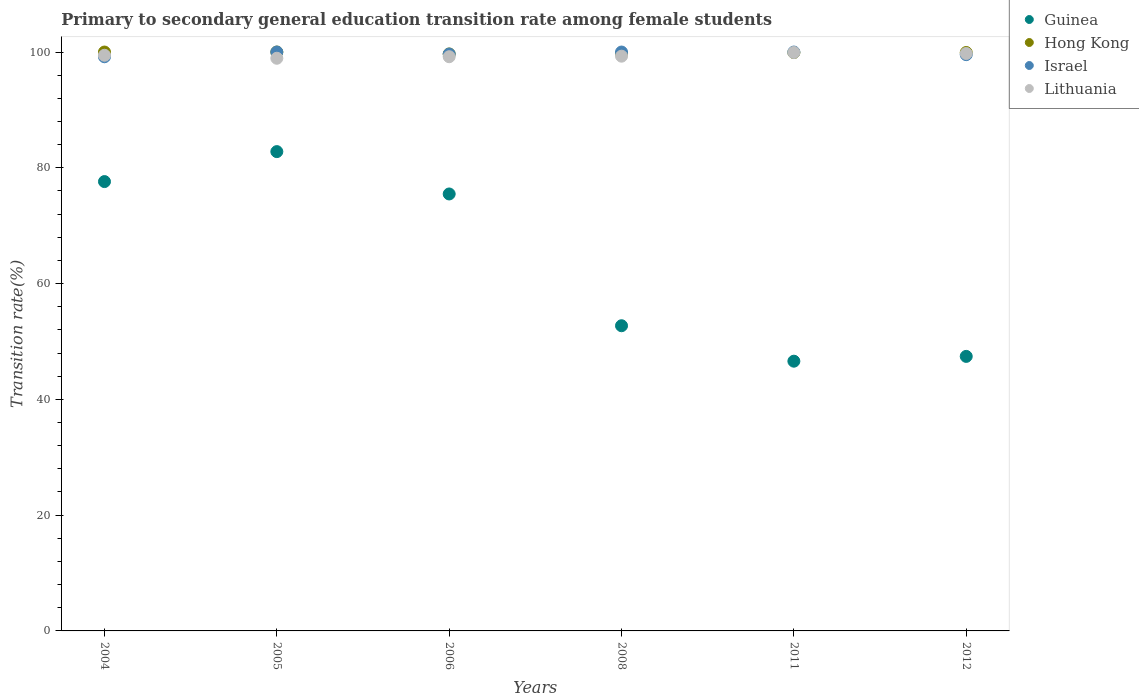What is the transition rate in Hong Kong in 2011?
Your response must be concise. 99.9. Across all years, what is the maximum transition rate in Hong Kong?
Give a very brief answer. 100. Across all years, what is the minimum transition rate in Guinea?
Keep it short and to the point. 46.59. In which year was the transition rate in Hong Kong maximum?
Provide a short and direct response. 2004. What is the total transition rate in Guinea in the graph?
Your answer should be compact. 382.64. What is the difference between the transition rate in Lithuania in 2008 and that in 2012?
Your answer should be very brief. -0.47. What is the difference between the transition rate in Lithuania in 2008 and the transition rate in Israel in 2012?
Your answer should be compact. -0.26. What is the average transition rate in Guinea per year?
Offer a very short reply. 63.77. In the year 2006, what is the difference between the transition rate in Hong Kong and transition rate in Guinea?
Your answer should be compact. 24.19. In how many years, is the transition rate in Guinea greater than 44 %?
Give a very brief answer. 6. What is the ratio of the transition rate in Israel in 2011 to that in 2012?
Offer a very short reply. 1. Is the difference between the transition rate in Hong Kong in 2005 and 2011 greater than the difference between the transition rate in Guinea in 2005 and 2011?
Your answer should be compact. No. What is the difference between the highest and the second highest transition rate in Hong Kong?
Your response must be concise. 0. What is the difference between the highest and the lowest transition rate in Israel?
Your answer should be compact. 0.82. Is it the case that in every year, the sum of the transition rate in Lithuania and transition rate in Israel  is greater than the sum of transition rate in Guinea and transition rate in Hong Kong?
Ensure brevity in your answer.  Yes. Is it the case that in every year, the sum of the transition rate in Hong Kong and transition rate in Israel  is greater than the transition rate in Lithuania?
Your response must be concise. Yes. Does the transition rate in Lithuania monotonically increase over the years?
Your answer should be very brief. No. Is the transition rate in Lithuania strictly greater than the transition rate in Guinea over the years?
Provide a short and direct response. Yes. Is the transition rate in Lithuania strictly less than the transition rate in Israel over the years?
Provide a succinct answer. No. How many dotlines are there?
Provide a short and direct response. 4. What is the difference between two consecutive major ticks on the Y-axis?
Offer a terse response. 20. Are the values on the major ticks of Y-axis written in scientific E-notation?
Offer a very short reply. No. Does the graph contain grids?
Provide a succinct answer. No. Where does the legend appear in the graph?
Offer a terse response. Top right. How are the legend labels stacked?
Ensure brevity in your answer.  Vertical. What is the title of the graph?
Keep it short and to the point. Primary to secondary general education transition rate among female students. Does "Samoa" appear as one of the legend labels in the graph?
Make the answer very short. No. What is the label or title of the Y-axis?
Make the answer very short. Transition rate(%). What is the Transition rate(%) in Guinea in 2004?
Your response must be concise. 77.62. What is the Transition rate(%) of Israel in 2004?
Keep it short and to the point. 99.18. What is the Transition rate(%) in Lithuania in 2004?
Offer a terse response. 99.44. What is the Transition rate(%) in Guinea in 2005?
Make the answer very short. 82.8. What is the Transition rate(%) in Israel in 2005?
Provide a short and direct response. 100. What is the Transition rate(%) in Lithuania in 2005?
Your answer should be very brief. 98.93. What is the Transition rate(%) of Guinea in 2006?
Provide a succinct answer. 75.48. What is the Transition rate(%) in Hong Kong in 2006?
Make the answer very short. 99.67. What is the Transition rate(%) in Israel in 2006?
Provide a short and direct response. 99.65. What is the Transition rate(%) of Lithuania in 2006?
Offer a terse response. 99.19. What is the Transition rate(%) of Guinea in 2008?
Offer a very short reply. 52.72. What is the Transition rate(%) in Hong Kong in 2008?
Offer a terse response. 99.7. What is the Transition rate(%) in Lithuania in 2008?
Your answer should be compact. 99.28. What is the Transition rate(%) of Guinea in 2011?
Your answer should be compact. 46.59. What is the Transition rate(%) in Hong Kong in 2011?
Offer a very short reply. 99.9. What is the Transition rate(%) in Israel in 2011?
Provide a succinct answer. 100. What is the Transition rate(%) of Lithuania in 2011?
Make the answer very short. 99.92. What is the Transition rate(%) of Guinea in 2012?
Offer a very short reply. 47.42. What is the Transition rate(%) of Hong Kong in 2012?
Make the answer very short. 99.92. What is the Transition rate(%) of Israel in 2012?
Your answer should be very brief. 99.55. What is the Transition rate(%) in Lithuania in 2012?
Keep it short and to the point. 99.75. Across all years, what is the maximum Transition rate(%) in Guinea?
Offer a very short reply. 82.8. Across all years, what is the maximum Transition rate(%) in Lithuania?
Give a very brief answer. 99.92. Across all years, what is the minimum Transition rate(%) in Guinea?
Your answer should be compact. 46.59. Across all years, what is the minimum Transition rate(%) of Hong Kong?
Offer a terse response. 99.67. Across all years, what is the minimum Transition rate(%) of Israel?
Give a very brief answer. 99.18. Across all years, what is the minimum Transition rate(%) in Lithuania?
Keep it short and to the point. 98.93. What is the total Transition rate(%) in Guinea in the graph?
Give a very brief answer. 382.64. What is the total Transition rate(%) in Hong Kong in the graph?
Your answer should be compact. 599.19. What is the total Transition rate(%) of Israel in the graph?
Make the answer very short. 598.38. What is the total Transition rate(%) in Lithuania in the graph?
Your answer should be very brief. 596.51. What is the difference between the Transition rate(%) of Guinea in 2004 and that in 2005?
Keep it short and to the point. -5.18. What is the difference between the Transition rate(%) of Hong Kong in 2004 and that in 2005?
Your answer should be very brief. 0. What is the difference between the Transition rate(%) in Israel in 2004 and that in 2005?
Your answer should be compact. -0.82. What is the difference between the Transition rate(%) in Lithuania in 2004 and that in 2005?
Your answer should be compact. 0.52. What is the difference between the Transition rate(%) of Guinea in 2004 and that in 2006?
Provide a succinct answer. 2.14. What is the difference between the Transition rate(%) of Hong Kong in 2004 and that in 2006?
Offer a very short reply. 0.33. What is the difference between the Transition rate(%) of Israel in 2004 and that in 2006?
Keep it short and to the point. -0.47. What is the difference between the Transition rate(%) in Lithuania in 2004 and that in 2006?
Your response must be concise. 0.25. What is the difference between the Transition rate(%) of Guinea in 2004 and that in 2008?
Your answer should be compact. 24.9. What is the difference between the Transition rate(%) of Hong Kong in 2004 and that in 2008?
Offer a terse response. 0.3. What is the difference between the Transition rate(%) of Israel in 2004 and that in 2008?
Ensure brevity in your answer.  -0.82. What is the difference between the Transition rate(%) of Lithuania in 2004 and that in 2008?
Your answer should be very brief. 0.16. What is the difference between the Transition rate(%) of Guinea in 2004 and that in 2011?
Ensure brevity in your answer.  31.03. What is the difference between the Transition rate(%) in Hong Kong in 2004 and that in 2011?
Ensure brevity in your answer.  0.1. What is the difference between the Transition rate(%) in Israel in 2004 and that in 2011?
Make the answer very short. -0.82. What is the difference between the Transition rate(%) of Lithuania in 2004 and that in 2011?
Your answer should be very brief. -0.47. What is the difference between the Transition rate(%) of Guinea in 2004 and that in 2012?
Your response must be concise. 30.2. What is the difference between the Transition rate(%) of Hong Kong in 2004 and that in 2012?
Make the answer very short. 0.08. What is the difference between the Transition rate(%) of Israel in 2004 and that in 2012?
Your answer should be very brief. -0.36. What is the difference between the Transition rate(%) of Lithuania in 2004 and that in 2012?
Give a very brief answer. -0.3. What is the difference between the Transition rate(%) in Guinea in 2005 and that in 2006?
Keep it short and to the point. 7.32. What is the difference between the Transition rate(%) in Hong Kong in 2005 and that in 2006?
Keep it short and to the point. 0.33. What is the difference between the Transition rate(%) of Israel in 2005 and that in 2006?
Ensure brevity in your answer.  0.35. What is the difference between the Transition rate(%) of Lithuania in 2005 and that in 2006?
Provide a succinct answer. -0.26. What is the difference between the Transition rate(%) in Guinea in 2005 and that in 2008?
Provide a succinct answer. 30.08. What is the difference between the Transition rate(%) of Hong Kong in 2005 and that in 2008?
Offer a terse response. 0.3. What is the difference between the Transition rate(%) of Israel in 2005 and that in 2008?
Keep it short and to the point. 0. What is the difference between the Transition rate(%) of Lithuania in 2005 and that in 2008?
Your answer should be compact. -0.36. What is the difference between the Transition rate(%) in Guinea in 2005 and that in 2011?
Make the answer very short. 36.2. What is the difference between the Transition rate(%) of Hong Kong in 2005 and that in 2011?
Provide a short and direct response. 0.1. What is the difference between the Transition rate(%) in Lithuania in 2005 and that in 2011?
Your answer should be compact. -0.99. What is the difference between the Transition rate(%) of Guinea in 2005 and that in 2012?
Ensure brevity in your answer.  35.37. What is the difference between the Transition rate(%) in Hong Kong in 2005 and that in 2012?
Provide a succinct answer. 0.08. What is the difference between the Transition rate(%) of Israel in 2005 and that in 2012?
Your response must be concise. 0.45. What is the difference between the Transition rate(%) in Lithuania in 2005 and that in 2012?
Offer a very short reply. -0.82. What is the difference between the Transition rate(%) in Guinea in 2006 and that in 2008?
Keep it short and to the point. 22.76. What is the difference between the Transition rate(%) in Hong Kong in 2006 and that in 2008?
Your answer should be very brief. -0.03. What is the difference between the Transition rate(%) of Israel in 2006 and that in 2008?
Offer a terse response. -0.35. What is the difference between the Transition rate(%) of Lithuania in 2006 and that in 2008?
Offer a very short reply. -0.09. What is the difference between the Transition rate(%) of Guinea in 2006 and that in 2011?
Provide a succinct answer. 28.89. What is the difference between the Transition rate(%) of Hong Kong in 2006 and that in 2011?
Offer a terse response. -0.24. What is the difference between the Transition rate(%) of Israel in 2006 and that in 2011?
Ensure brevity in your answer.  -0.35. What is the difference between the Transition rate(%) of Lithuania in 2006 and that in 2011?
Give a very brief answer. -0.73. What is the difference between the Transition rate(%) in Guinea in 2006 and that in 2012?
Provide a succinct answer. 28.06. What is the difference between the Transition rate(%) in Hong Kong in 2006 and that in 2012?
Keep it short and to the point. -0.25. What is the difference between the Transition rate(%) in Israel in 2006 and that in 2012?
Provide a succinct answer. 0.1. What is the difference between the Transition rate(%) of Lithuania in 2006 and that in 2012?
Provide a succinct answer. -0.56. What is the difference between the Transition rate(%) in Guinea in 2008 and that in 2011?
Ensure brevity in your answer.  6.12. What is the difference between the Transition rate(%) in Hong Kong in 2008 and that in 2011?
Provide a succinct answer. -0.2. What is the difference between the Transition rate(%) of Lithuania in 2008 and that in 2011?
Give a very brief answer. -0.63. What is the difference between the Transition rate(%) in Guinea in 2008 and that in 2012?
Offer a terse response. 5.29. What is the difference between the Transition rate(%) of Hong Kong in 2008 and that in 2012?
Provide a short and direct response. -0.22. What is the difference between the Transition rate(%) in Israel in 2008 and that in 2012?
Give a very brief answer. 0.45. What is the difference between the Transition rate(%) in Lithuania in 2008 and that in 2012?
Give a very brief answer. -0.47. What is the difference between the Transition rate(%) in Guinea in 2011 and that in 2012?
Offer a terse response. -0.83. What is the difference between the Transition rate(%) of Hong Kong in 2011 and that in 2012?
Provide a short and direct response. -0.01. What is the difference between the Transition rate(%) in Israel in 2011 and that in 2012?
Your answer should be very brief. 0.45. What is the difference between the Transition rate(%) in Lithuania in 2011 and that in 2012?
Ensure brevity in your answer.  0.17. What is the difference between the Transition rate(%) of Guinea in 2004 and the Transition rate(%) of Hong Kong in 2005?
Offer a very short reply. -22.38. What is the difference between the Transition rate(%) of Guinea in 2004 and the Transition rate(%) of Israel in 2005?
Give a very brief answer. -22.38. What is the difference between the Transition rate(%) in Guinea in 2004 and the Transition rate(%) in Lithuania in 2005?
Keep it short and to the point. -21.3. What is the difference between the Transition rate(%) of Hong Kong in 2004 and the Transition rate(%) of Israel in 2005?
Your answer should be very brief. 0. What is the difference between the Transition rate(%) in Hong Kong in 2004 and the Transition rate(%) in Lithuania in 2005?
Your answer should be compact. 1.07. What is the difference between the Transition rate(%) in Israel in 2004 and the Transition rate(%) in Lithuania in 2005?
Make the answer very short. 0.26. What is the difference between the Transition rate(%) in Guinea in 2004 and the Transition rate(%) in Hong Kong in 2006?
Make the answer very short. -22.05. What is the difference between the Transition rate(%) in Guinea in 2004 and the Transition rate(%) in Israel in 2006?
Offer a terse response. -22.03. What is the difference between the Transition rate(%) in Guinea in 2004 and the Transition rate(%) in Lithuania in 2006?
Provide a succinct answer. -21.57. What is the difference between the Transition rate(%) of Hong Kong in 2004 and the Transition rate(%) of Israel in 2006?
Offer a terse response. 0.35. What is the difference between the Transition rate(%) in Hong Kong in 2004 and the Transition rate(%) in Lithuania in 2006?
Your answer should be compact. 0.81. What is the difference between the Transition rate(%) in Israel in 2004 and the Transition rate(%) in Lithuania in 2006?
Ensure brevity in your answer.  -0.01. What is the difference between the Transition rate(%) of Guinea in 2004 and the Transition rate(%) of Hong Kong in 2008?
Offer a very short reply. -22.08. What is the difference between the Transition rate(%) of Guinea in 2004 and the Transition rate(%) of Israel in 2008?
Your answer should be compact. -22.38. What is the difference between the Transition rate(%) in Guinea in 2004 and the Transition rate(%) in Lithuania in 2008?
Provide a short and direct response. -21.66. What is the difference between the Transition rate(%) in Hong Kong in 2004 and the Transition rate(%) in Lithuania in 2008?
Keep it short and to the point. 0.72. What is the difference between the Transition rate(%) of Israel in 2004 and the Transition rate(%) of Lithuania in 2008?
Ensure brevity in your answer.  -0.1. What is the difference between the Transition rate(%) of Guinea in 2004 and the Transition rate(%) of Hong Kong in 2011?
Ensure brevity in your answer.  -22.28. What is the difference between the Transition rate(%) in Guinea in 2004 and the Transition rate(%) in Israel in 2011?
Your answer should be very brief. -22.38. What is the difference between the Transition rate(%) of Guinea in 2004 and the Transition rate(%) of Lithuania in 2011?
Ensure brevity in your answer.  -22.3. What is the difference between the Transition rate(%) in Hong Kong in 2004 and the Transition rate(%) in Israel in 2011?
Your response must be concise. 0. What is the difference between the Transition rate(%) in Hong Kong in 2004 and the Transition rate(%) in Lithuania in 2011?
Ensure brevity in your answer.  0.08. What is the difference between the Transition rate(%) of Israel in 2004 and the Transition rate(%) of Lithuania in 2011?
Offer a very short reply. -0.74. What is the difference between the Transition rate(%) in Guinea in 2004 and the Transition rate(%) in Hong Kong in 2012?
Offer a terse response. -22.3. What is the difference between the Transition rate(%) of Guinea in 2004 and the Transition rate(%) of Israel in 2012?
Your answer should be compact. -21.93. What is the difference between the Transition rate(%) of Guinea in 2004 and the Transition rate(%) of Lithuania in 2012?
Your response must be concise. -22.13. What is the difference between the Transition rate(%) of Hong Kong in 2004 and the Transition rate(%) of Israel in 2012?
Provide a short and direct response. 0.45. What is the difference between the Transition rate(%) in Hong Kong in 2004 and the Transition rate(%) in Lithuania in 2012?
Offer a terse response. 0.25. What is the difference between the Transition rate(%) in Israel in 2004 and the Transition rate(%) in Lithuania in 2012?
Your response must be concise. -0.57. What is the difference between the Transition rate(%) of Guinea in 2005 and the Transition rate(%) of Hong Kong in 2006?
Keep it short and to the point. -16.87. What is the difference between the Transition rate(%) in Guinea in 2005 and the Transition rate(%) in Israel in 2006?
Your response must be concise. -16.85. What is the difference between the Transition rate(%) in Guinea in 2005 and the Transition rate(%) in Lithuania in 2006?
Keep it short and to the point. -16.39. What is the difference between the Transition rate(%) of Hong Kong in 2005 and the Transition rate(%) of Israel in 2006?
Make the answer very short. 0.35. What is the difference between the Transition rate(%) in Hong Kong in 2005 and the Transition rate(%) in Lithuania in 2006?
Ensure brevity in your answer.  0.81. What is the difference between the Transition rate(%) in Israel in 2005 and the Transition rate(%) in Lithuania in 2006?
Provide a succinct answer. 0.81. What is the difference between the Transition rate(%) in Guinea in 2005 and the Transition rate(%) in Hong Kong in 2008?
Keep it short and to the point. -16.9. What is the difference between the Transition rate(%) in Guinea in 2005 and the Transition rate(%) in Israel in 2008?
Offer a terse response. -17.2. What is the difference between the Transition rate(%) of Guinea in 2005 and the Transition rate(%) of Lithuania in 2008?
Offer a very short reply. -16.49. What is the difference between the Transition rate(%) in Hong Kong in 2005 and the Transition rate(%) in Lithuania in 2008?
Provide a succinct answer. 0.72. What is the difference between the Transition rate(%) of Israel in 2005 and the Transition rate(%) of Lithuania in 2008?
Ensure brevity in your answer.  0.72. What is the difference between the Transition rate(%) of Guinea in 2005 and the Transition rate(%) of Hong Kong in 2011?
Your answer should be very brief. -17.11. What is the difference between the Transition rate(%) of Guinea in 2005 and the Transition rate(%) of Israel in 2011?
Offer a terse response. -17.2. What is the difference between the Transition rate(%) of Guinea in 2005 and the Transition rate(%) of Lithuania in 2011?
Provide a succinct answer. -17.12. What is the difference between the Transition rate(%) in Hong Kong in 2005 and the Transition rate(%) in Israel in 2011?
Provide a short and direct response. 0. What is the difference between the Transition rate(%) of Hong Kong in 2005 and the Transition rate(%) of Lithuania in 2011?
Keep it short and to the point. 0.08. What is the difference between the Transition rate(%) of Israel in 2005 and the Transition rate(%) of Lithuania in 2011?
Provide a succinct answer. 0.08. What is the difference between the Transition rate(%) of Guinea in 2005 and the Transition rate(%) of Hong Kong in 2012?
Your response must be concise. -17.12. What is the difference between the Transition rate(%) of Guinea in 2005 and the Transition rate(%) of Israel in 2012?
Your answer should be compact. -16.75. What is the difference between the Transition rate(%) of Guinea in 2005 and the Transition rate(%) of Lithuania in 2012?
Your answer should be very brief. -16.95. What is the difference between the Transition rate(%) in Hong Kong in 2005 and the Transition rate(%) in Israel in 2012?
Offer a terse response. 0.45. What is the difference between the Transition rate(%) of Hong Kong in 2005 and the Transition rate(%) of Lithuania in 2012?
Your response must be concise. 0.25. What is the difference between the Transition rate(%) of Israel in 2005 and the Transition rate(%) of Lithuania in 2012?
Provide a short and direct response. 0.25. What is the difference between the Transition rate(%) in Guinea in 2006 and the Transition rate(%) in Hong Kong in 2008?
Give a very brief answer. -24.22. What is the difference between the Transition rate(%) of Guinea in 2006 and the Transition rate(%) of Israel in 2008?
Give a very brief answer. -24.52. What is the difference between the Transition rate(%) of Guinea in 2006 and the Transition rate(%) of Lithuania in 2008?
Make the answer very short. -23.8. What is the difference between the Transition rate(%) in Hong Kong in 2006 and the Transition rate(%) in Israel in 2008?
Your answer should be compact. -0.33. What is the difference between the Transition rate(%) of Hong Kong in 2006 and the Transition rate(%) of Lithuania in 2008?
Your answer should be compact. 0.38. What is the difference between the Transition rate(%) in Israel in 2006 and the Transition rate(%) in Lithuania in 2008?
Give a very brief answer. 0.37. What is the difference between the Transition rate(%) in Guinea in 2006 and the Transition rate(%) in Hong Kong in 2011?
Keep it short and to the point. -24.42. What is the difference between the Transition rate(%) of Guinea in 2006 and the Transition rate(%) of Israel in 2011?
Your answer should be very brief. -24.52. What is the difference between the Transition rate(%) in Guinea in 2006 and the Transition rate(%) in Lithuania in 2011?
Provide a short and direct response. -24.44. What is the difference between the Transition rate(%) in Hong Kong in 2006 and the Transition rate(%) in Israel in 2011?
Your answer should be very brief. -0.33. What is the difference between the Transition rate(%) in Hong Kong in 2006 and the Transition rate(%) in Lithuania in 2011?
Offer a terse response. -0.25. What is the difference between the Transition rate(%) of Israel in 2006 and the Transition rate(%) of Lithuania in 2011?
Offer a very short reply. -0.27. What is the difference between the Transition rate(%) in Guinea in 2006 and the Transition rate(%) in Hong Kong in 2012?
Give a very brief answer. -24.44. What is the difference between the Transition rate(%) in Guinea in 2006 and the Transition rate(%) in Israel in 2012?
Your answer should be very brief. -24.07. What is the difference between the Transition rate(%) in Guinea in 2006 and the Transition rate(%) in Lithuania in 2012?
Ensure brevity in your answer.  -24.27. What is the difference between the Transition rate(%) of Hong Kong in 2006 and the Transition rate(%) of Israel in 2012?
Make the answer very short. 0.12. What is the difference between the Transition rate(%) of Hong Kong in 2006 and the Transition rate(%) of Lithuania in 2012?
Make the answer very short. -0.08. What is the difference between the Transition rate(%) of Israel in 2006 and the Transition rate(%) of Lithuania in 2012?
Provide a short and direct response. -0.1. What is the difference between the Transition rate(%) in Guinea in 2008 and the Transition rate(%) in Hong Kong in 2011?
Make the answer very short. -47.19. What is the difference between the Transition rate(%) in Guinea in 2008 and the Transition rate(%) in Israel in 2011?
Offer a terse response. -47.28. What is the difference between the Transition rate(%) of Guinea in 2008 and the Transition rate(%) of Lithuania in 2011?
Keep it short and to the point. -47.2. What is the difference between the Transition rate(%) of Hong Kong in 2008 and the Transition rate(%) of Israel in 2011?
Give a very brief answer. -0.3. What is the difference between the Transition rate(%) in Hong Kong in 2008 and the Transition rate(%) in Lithuania in 2011?
Your answer should be compact. -0.22. What is the difference between the Transition rate(%) of Israel in 2008 and the Transition rate(%) of Lithuania in 2011?
Offer a terse response. 0.08. What is the difference between the Transition rate(%) of Guinea in 2008 and the Transition rate(%) of Hong Kong in 2012?
Provide a succinct answer. -47.2. What is the difference between the Transition rate(%) of Guinea in 2008 and the Transition rate(%) of Israel in 2012?
Provide a short and direct response. -46.83. What is the difference between the Transition rate(%) in Guinea in 2008 and the Transition rate(%) in Lithuania in 2012?
Offer a very short reply. -47.03. What is the difference between the Transition rate(%) of Hong Kong in 2008 and the Transition rate(%) of Israel in 2012?
Give a very brief answer. 0.16. What is the difference between the Transition rate(%) in Hong Kong in 2008 and the Transition rate(%) in Lithuania in 2012?
Provide a short and direct response. -0.05. What is the difference between the Transition rate(%) of Israel in 2008 and the Transition rate(%) of Lithuania in 2012?
Offer a very short reply. 0.25. What is the difference between the Transition rate(%) in Guinea in 2011 and the Transition rate(%) in Hong Kong in 2012?
Make the answer very short. -53.32. What is the difference between the Transition rate(%) of Guinea in 2011 and the Transition rate(%) of Israel in 2012?
Your response must be concise. -52.95. What is the difference between the Transition rate(%) of Guinea in 2011 and the Transition rate(%) of Lithuania in 2012?
Provide a succinct answer. -53.15. What is the difference between the Transition rate(%) in Hong Kong in 2011 and the Transition rate(%) in Israel in 2012?
Give a very brief answer. 0.36. What is the difference between the Transition rate(%) of Hong Kong in 2011 and the Transition rate(%) of Lithuania in 2012?
Your answer should be compact. 0.16. What is the difference between the Transition rate(%) of Israel in 2011 and the Transition rate(%) of Lithuania in 2012?
Provide a short and direct response. 0.25. What is the average Transition rate(%) of Guinea per year?
Ensure brevity in your answer.  63.77. What is the average Transition rate(%) in Hong Kong per year?
Give a very brief answer. 99.87. What is the average Transition rate(%) of Israel per year?
Offer a very short reply. 99.73. What is the average Transition rate(%) of Lithuania per year?
Your answer should be compact. 99.42. In the year 2004, what is the difference between the Transition rate(%) of Guinea and Transition rate(%) of Hong Kong?
Keep it short and to the point. -22.38. In the year 2004, what is the difference between the Transition rate(%) of Guinea and Transition rate(%) of Israel?
Offer a terse response. -21.56. In the year 2004, what is the difference between the Transition rate(%) of Guinea and Transition rate(%) of Lithuania?
Your answer should be very brief. -21.82. In the year 2004, what is the difference between the Transition rate(%) of Hong Kong and Transition rate(%) of Israel?
Keep it short and to the point. 0.82. In the year 2004, what is the difference between the Transition rate(%) in Hong Kong and Transition rate(%) in Lithuania?
Offer a terse response. 0.56. In the year 2004, what is the difference between the Transition rate(%) of Israel and Transition rate(%) of Lithuania?
Keep it short and to the point. -0.26. In the year 2005, what is the difference between the Transition rate(%) of Guinea and Transition rate(%) of Hong Kong?
Give a very brief answer. -17.2. In the year 2005, what is the difference between the Transition rate(%) in Guinea and Transition rate(%) in Israel?
Provide a short and direct response. -17.2. In the year 2005, what is the difference between the Transition rate(%) of Guinea and Transition rate(%) of Lithuania?
Keep it short and to the point. -16.13. In the year 2005, what is the difference between the Transition rate(%) in Hong Kong and Transition rate(%) in Lithuania?
Your answer should be compact. 1.07. In the year 2005, what is the difference between the Transition rate(%) in Israel and Transition rate(%) in Lithuania?
Your answer should be very brief. 1.07. In the year 2006, what is the difference between the Transition rate(%) in Guinea and Transition rate(%) in Hong Kong?
Offer a very short reply. -24.19. In the year 2006, what is the difference between the Transition rate(%) of Guinea and Transition rate(%) of Israel?
Give a very brief answer. -24.17. In the year 2006, what is the difference between the Transition rate(%) in Guinea and Transition rate(%) in Lithuania?
Ensure brevity in your answer.  -23.71. In the year 2006, what is the difference between the Transition rate(%) in Hong Kong and Transition rate(%) in Israel?
Give a very brief answer. 0.02. In the year 2006, what is the difference between the Transition rate(%) of Hong Kong and Transition rate(%) of Lithuania?
Your answer should be compact. 0.48. In the year 2006, what is the difference between the Transition rate(%) of Israel and Transition rate(%) of Lithuania?
Offer a terse response. 0.46. In the year 2008, what is the difference between the Transition rate(%) in Guinea and Transition rate(%) in Hong Kong?
Your answer should be compact. -46.98. In the year 2008, what is the difference between the Transition rate(%) in Guinea and Transition rate(%) in Israel?
Provide a succinct answer. -47.28. In the year 2008, what is the difference between the Transition rate(%) of Guinea and Transition rate(%) of Lithuania?
Your answer should be compact. -46.56. In the year 2008, what is the difference between the Transition rate(%) in Hong Kong and Transition rate(%) in Israel?
Give a very brief answer. -0.3. In the year 2008, what is the difference between the Transition rate(%) in Hong Kong and Transition rate(%) in Lithuania?
Keep it short and to the point. 0.42. In the year 2008, what is the difference between the Transition rate(%) in Israel and Transition rate(%) in Lithuania?
Provide a short and direct response. 0.72. In the year 2011, what is the difference between the Transition rate(%) of Guinea and Transition rate(%) of Hong Kong?
Provide a succinct answer. -53.31. In the year 2011, what is the difference between the Transition rate(%) of Guinea and Transition rate(%) of Israel?
Provide a short and direct response. -53.41. In the year 2011, what is the difference between the Transition rate(%) of Guinea and Transition rate(%) of Lithuania?
Your answer should be very brief. -53.32. In the year 2011, what is the difference between the Transition rate(%) in Hong Kong and Transition rate(%) in Israel?
Your answer should be very brief. -0.1. In the year 2011, what is the difference between the Transition rate(%) of Hong Kong and Transition rate(%) of Lithuania?
Offer a very short reply. -0.01. In the year 2011, what is the difference between the Transition rate(%) in Israel and Transition rate(%) in Lithuania?
Your answer should be compact. 0.08. In the year 2012, what is the difference between the Transition rate(%) of Guinea and Transition rate(%) of Hong Kong?
Provide a succinct answer. -52.49. In the year 2012, what is the difference between the Transition rate(%) of Guinea and Transition rate(%) of Israel?
Provide a succinct answer. -52.12. In the year 2012, what is the difference between the Transition rate(%) of Guinea and Transition rate(%) of Lithuania?
Your answer should be very brief. -52.32. In the year 2012, what is the difference between the Transition rate(%) in Hong Kong and Transition rate(%) in Israel?
Offer a terse response. 0.37. In the year 2012, what is the difference between the Transition rate(%) of Hong Kong and Transition rate(%) of Lithuania?
Provide a short and direct response. 0.17. In the year 2012, what is the difference between the Transition rate(%) of Israel and Transition rate(%) of Lithuania?
Provide a succinct answer. -0.2. What is the ratio of the Transition rate(%) of Hong Kong in 2004 to that in 2005?
Make the answer very short. 1. What is the ratio of the Transition rate(%) in Israel in 2004 to that in 2005?
Keep it short and to the point. 0.99. What is the ratio of the Transition rate(%) of Guinea in 2004 to that in 2006?
Your response must be concise. 1.03. What is the ratio of the Transition rate(%) in Guinea in 2004 to that in 2008?
Offer a very short reply. 1.47. What is the ratio of the Transition rate(%) in Israel in 2004 to that in 2008?
Ensure brevity in your answer.  0.99. What is the ratio of the Transition rate(%) in Lithuania in 2004 to that in 2008?
Ensure brevity in your answer.  1. What is the ratio of the Transition rate(%) in Guinea in 2004 to that in 2011?
Provide a succinct answer. 1.67. What is the ratio of the Transition rate(%) of Hong Kong in 2004 to that in 2011?
Keep it short and to the point. 1. What is the ratio of the Transition rate(%) of Israel in 2004 to that in 2011?
Ensure brevity in your answer.  0.99. What is the ratio of the Transition rate(%) of Guinea in 2004 to that in 2012?
Make the answer very short. 1.64. What is the ratio of the Transition rate(%) of Hong Kong in 2004 to that in 2012?
Offer a very short reply. 1. What is the ratio of the Transition rate(%) of Guinea in 2005 to that in 2006?
Your response must be concise. 1.1. What is the ratio of the Transition rate(%) in Hong Kong in 2005 to that in 2006?
Give a very brief answer. 1. What is the ratio of the Transition rate(%) of Israel in 2005 to that in 2006?
Keep it short and to the point. 1. What is the ratio of the Transition rate(%) in Lithuania in 2005 to that in 2006?
Offer a very short reply. 1. What is the ratio of the Transition rate(%) in Guinea in 2005 to that in 2008?
Provide a short and direct response. 1.57. What is the ratio of the Transition rate(%) of Hong Kong in 2005 to that in 2008?
Give a very brief answer. 1. What is the ratio of the Transition rate(%) of Israel in 2005 to that in 2008?
Your answer should be very brief. 1. What is the ratio of the Transition rate(%) in Lithuania in 2005 to that in 2008?
Ensure brevity in your answer.  1. What is the ratio of the Transition rate(%) in Guinea in 2005 to that in 2011?
Ensure brevity in your answer.  1.78. What is the ratio of the Transition rate(%) in Guinea in 2005 to that in 2012?
Provide a short and direct response. 1.75. What is the ratio of the Transition rate(%) in Hong Kong in 2005 to that in 2012?
Keep it short and to the point. 1. What is the ratio of the Transition rate(%) of Israel in 2005 to that in 2012?
Your answer should be compact. 1. What is the ratio of the Transition rate(%) in Guinea in 2006 to that in 2008?
Your answer should be compact. 1.43. What is the ratio of the Transition rate(%) in Israel in 2006 to that in 2008?
Your response must be concise. 1. What is the ratio of the Transition rate(%) of Lithuania in 2006 to that in 2008?
Offer a terse response. 1. What is the ratio of the Transition rate(%) in Guinea in 2006 to that in 2011?
Give a very brief answer. 1.62. What is the ratio of the Transition rate(%) in Hong Kong in 2006 to that in 2011?
Keep it short and to the point. 1. What is the ratio of the Transition rate(%) of Lithuania in 2006 to that in 2011?
Your response must be concise. 0.99. What is the ratio of the Transition rate(%) of Guinea in 2006 to that in 2012?
Make the answer very short. 1.59. What is the ratio of the Transition rate(%) in Israel in 2006 to that in 2012?
Ensure brevity in your answer.  1. What is the ratio of the Transition rate(%) of Lithuania in 2006 to that in 2012?
Your answer should be compact. 0.99. What is the ratio of the Transition rate(%) in Guinea in 2008 to that in 2011?
Offer a terse response. 1.13. What is the ratio of the Transition rate(%) of Hong Kong in 2008 to that in 2011?
Make the answer very short. 1. What is the ratio of the Transition rate(%) in Israel in 2008 to that in 2011?
Offer a terse response. 1. What is the ratio of the Transition rate(%) in Guinea in 2008 to that in 2012?
Your response must be concise. 1.11. What is the ratio of the Transition rate(%) of Hong Kong in 2008 to that in 2012?
Your answer should be very brief. 1. What is the ratio of the Transition rate(%) of Guinea in 2011 to that in 2012?
Your answer should be compact. 0.98. What is the ratio of the Transition rate(%) of Israel in 2011 to that in 2012?
Keep it short and to the point. 1. What is the difference between the highest and the second highest Transition rate(%) of Guinea?
Ensure brevity in your answer.  5.18. What is the difference between the highest and the second highest Transition rate(%) in Hong Kong?
Give a very brief answer. 0. What is the difference between the highest and the second highest Transition rate(%) of Israel?
Your response must be concise. 0. What is the difference between the highest and the second highest Transition rate(%) in Lithuania?
Offer a terse response. 0.17. What is the difference between the highest and the lowest Transition rate(%) in Guinea?
Make the answer very short. 36.2. What is the difference between the highest and the lowest Transition rate(%) of Hong Kong?
Make the answer very short. 0.33. What is the difference between the highest and the lowest Transition rate(%) in Israel?
Your answer should be compact. 0.82. What is the difference between the highest and the lowest Transition rate(%) in Lithuania?
Keep it short and to the point. 0.99. 